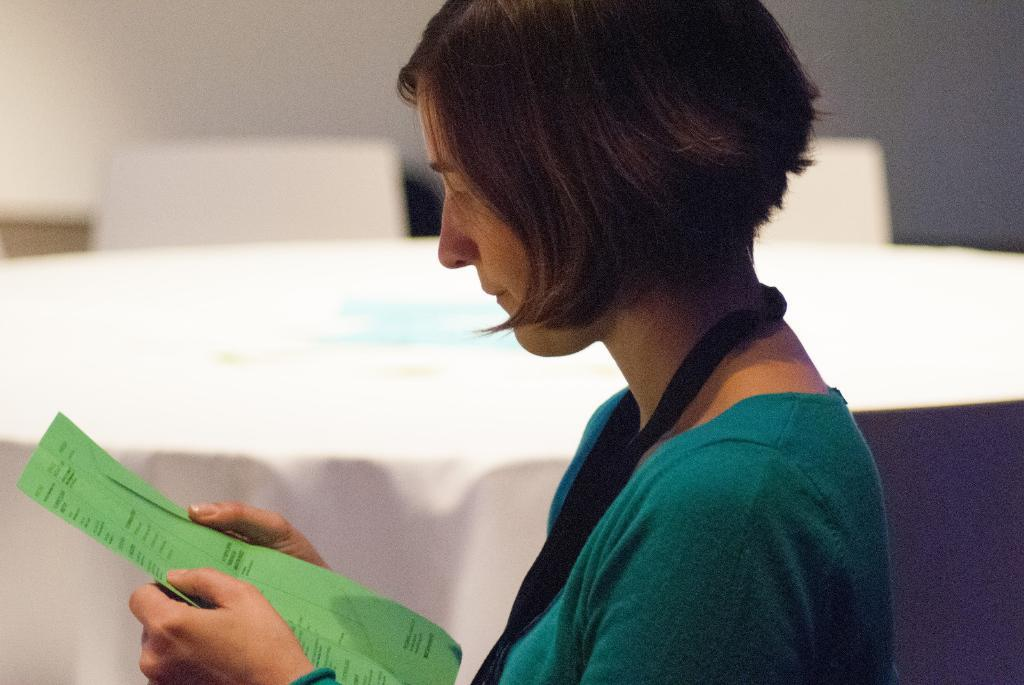What is present in the image? There is a woman in the image. What is the woman holding in her hand? The woman is holding a paper in her hand. What type of linen is the woman using to write on the paper? There is no linen present in the image, and the woman is not writing on the paper. What type of wax is being used to seal the paper? There is no wax present in the image, and the woman is not sealing the paper. 